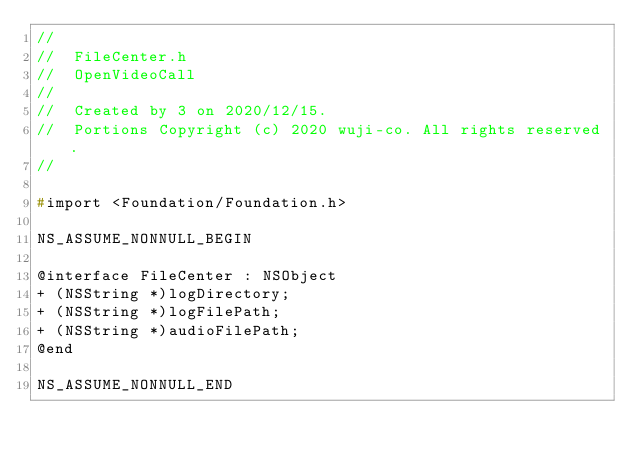Convert code to text. <code><loc_0><loc_0><loc_500><loc_500><_C_>//
//  FileCenter.h
//  OpenVideoCall
//
//  Created by 3 on 2020/12/15.
//  Portions Copyright (c) 2020 wuji-co. All rights reserved.
//

#import <Foundation/Foundation.h>

NS_ASSUME_NONNULL_BEGIN

@interface FileCenter : NSObject
+ (NSString *)logDirectory;
+ (NSString *)logFilePath;
+ (NSString *)audioFilePath;
@end

NS_ASSUME_NONNULL_END
</code> 